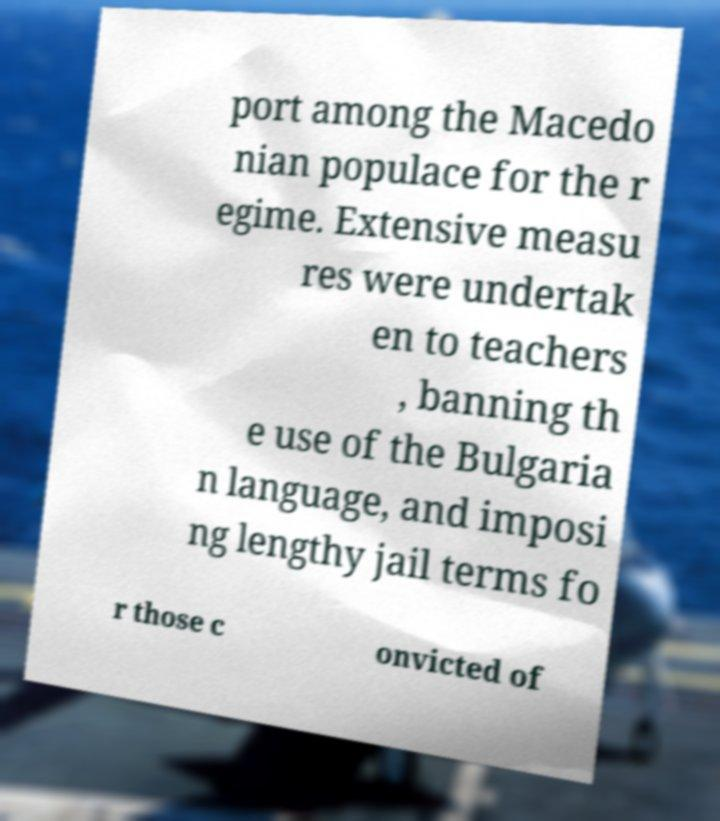I need the written content from this picture converted into text. Can you do that? port among the Macedo nian populace for the r egime. Extensive measu res were undertak en to teachers , banning th e use of the Bulgaria n language, and imposi ng lengthy jail terms fo r those c onvicted of 